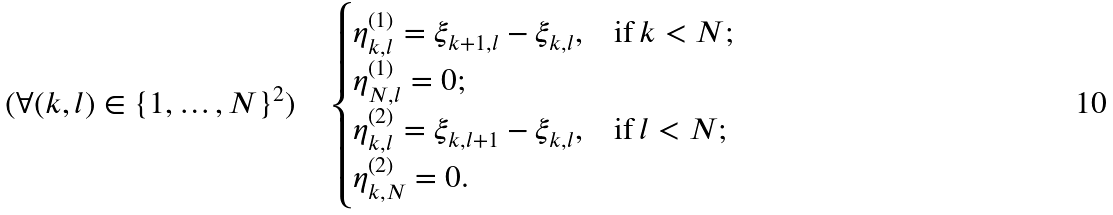Convert formula to latex. <formula><loc_0><loc_0><loc_500><loc_500>( \forall ( k , l ) \in \{ 1 , \dots , N \} ^ { 2 } ) \quad \begin{cases} \eta ^ { ( 1 ) } _ { k , l } = \xi _ { k + 1 , l } - \xi _ { k , l } , & \text {if} \, k < N ; \\ \eta ^ { ( 1 ) } _ { N , l } = 0 ; \\ \eta ^ { ( 2 ) } _ { k , l } = \xi _ { k , l + 1 } - \xi _ { k , l } , & \text {if} \, l < N ; \\ \eta ^ { ( 2 ) } _ { k , N } = 0 . \end{cases}</formula> 